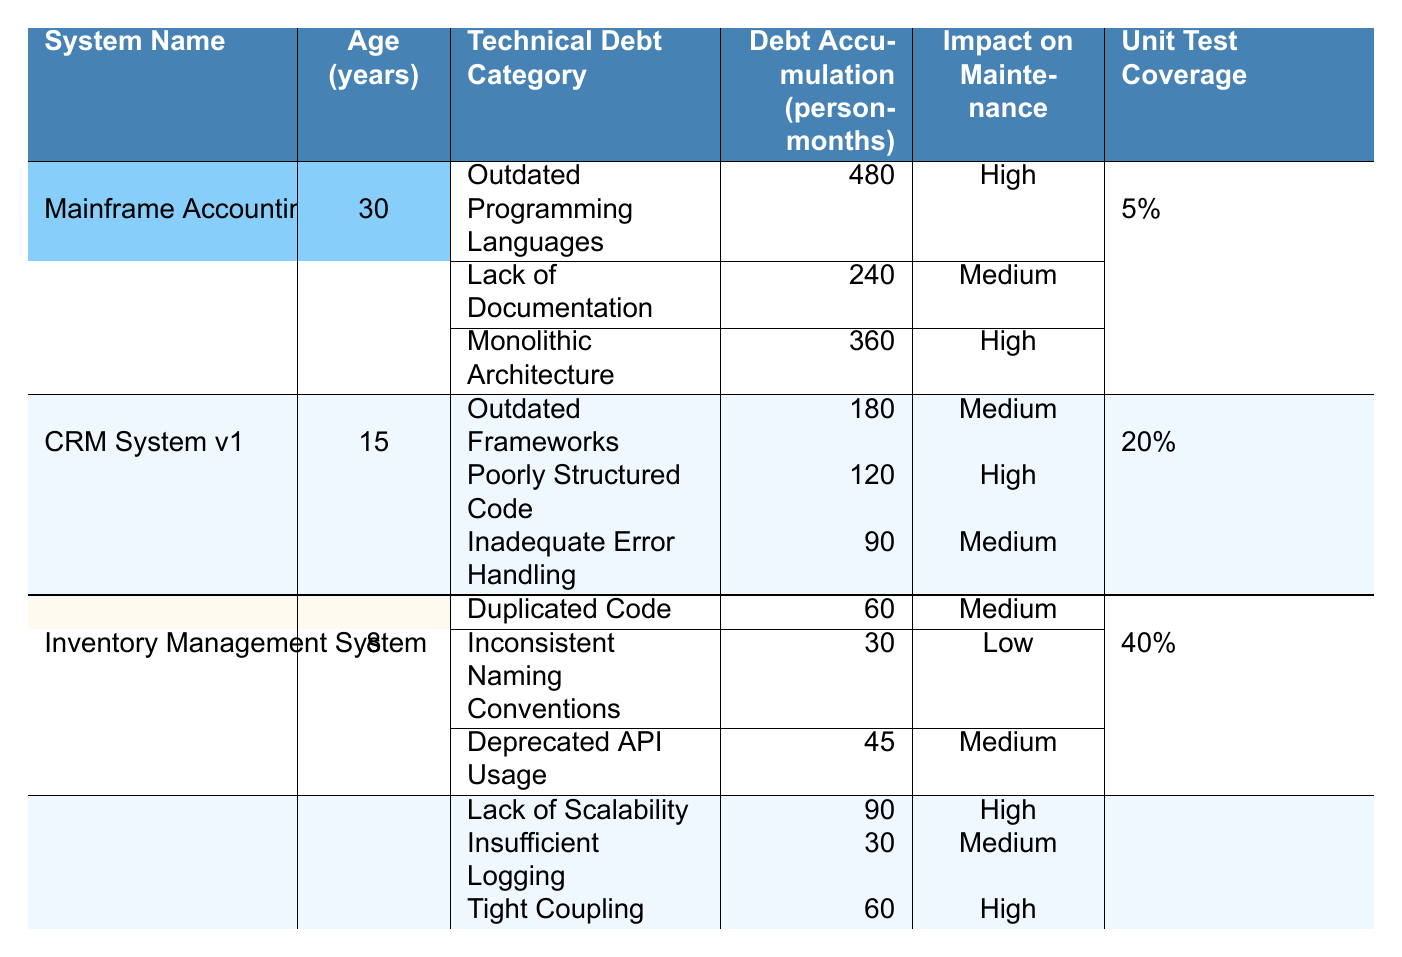What is the total debt accumulation for the "Mainframe Accounting System"? By referring to the "Technical Debt Categories" under the "Mainframe Accounting System", we sum the debt accumulation figures: 480 + 240 + 360 = 1080.
Answer: 1080 Which system has the highest unit test coverage? Looking at the "Unit Test Coverage" column, "Payment Gateway" has 60%, which is higher than the others: 5%, 20%, and 40%.
Answer: Payment Gateway What is the age of the "Inventory Management System"? The "Age (years)" for "Inventory Management System" is listed as 8 years.
Answer: 8 How many person-months of technical debt does the "CRM System v1" have in total? For "CRM System v1", we sum the values in the "Debt Accumulation (person-months)" column: 180 + 120 + 90 = 390.
Answer: 390 Is "Lack of Documentation" categorized as high impact on maintenance? Referring to the "Impact on Maintenance" for "Lack of Documentation", it is listed as "Medium". Therefore, it is not categorized as high.
Answer: No What is the impact on maintenance for "Outdated Programming Languages"? The "Impact on Maintenance" for this category under the "Mainframe Accounting System" is "High".
Answer: High Which legacy system category has the least technical debt accumulation overall? Assessing the total debt accumulations across all systems, "Inventory Management System" has the lowest at 60 + 30 + 45 = 135.
Answer: Inventory Management System How many categories of technical debt are classified as high impact across all systems? By analyzing the table, the high impact categories are: 3 for the Mainframe, 1 for CRM, 0 for Inventory, and 3 for Payment Gateway. Therefore, the total is 3 + 1 + 0 + 3 = 7.
Answer: 7 What is the average age of the legacy systems listed? Taking the ages: 30 + 15 + 8 + 5 = 58, and dividing by the total systems (4) gives us an average of 58 / 4 = 14.5 years.
Answer: 14.5 Which system has less than 40% unit test coverage? From the table, "Mainframe Accounting System" with 5%, "CRM System v1" at 20%, and "Inventory Management System" at 40% have less than 40%. However, since "Inventory Management" has exactly 40%, the systems with less are "Mainframe Accounting" and "CRM System v1".
Answer: Mainframe Accounting System, CRM System v1 